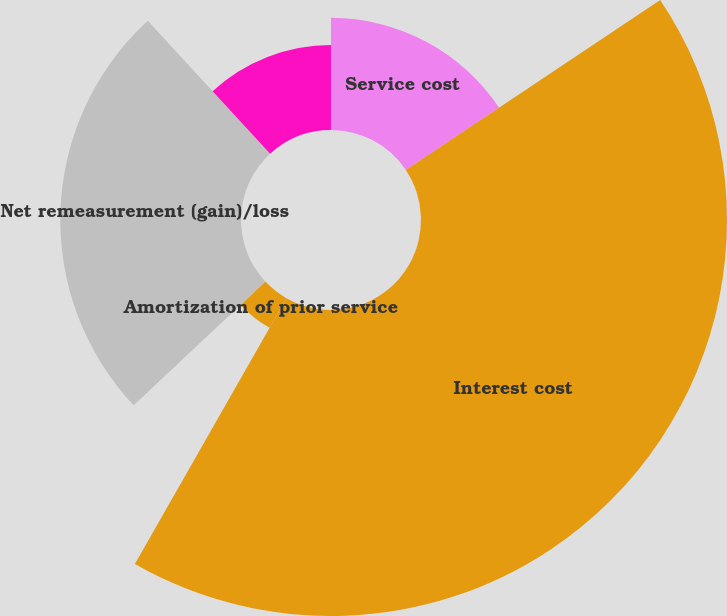Convert chart. <chart><loc_0><loc_0><loc_500><loc_500><pie_chart><fcel>Service cost<fcel>Interest cost<fcel>Amortization of prior service<fcel>Net remeasurement (gain)/loss<fcel>Net periodic benefit<nl><fcel>15.62%<fcel>42.62%<fcel>4.75%<fcel>25.17%<fcel>11.83%<nl></chart> 